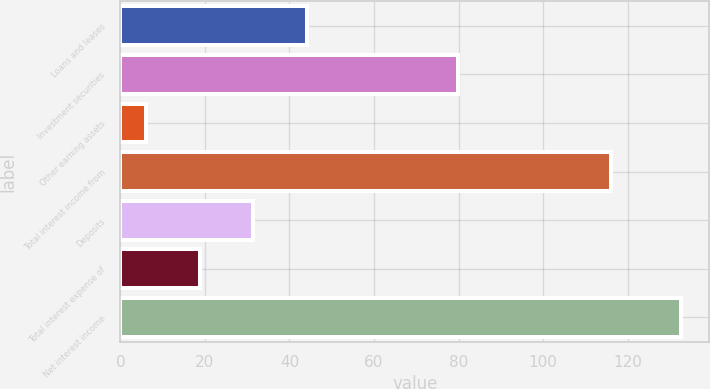Convert chart. <chart><loc_0><loc_0><loc_500><loc_500><bar_chart><fcel>Loans and leases<fcel>Investment securities<fcel>Other earning assets<fcel>Total interest income from<fcel>Deposits<fcel>Total interest expense of<fcel>Net interest income<nl><fcel>44.08<fcel>79.9<fcel>6.1<fcel>116<fcel>31.42<fcel>18.76<fcel>132.7<nl></chart> 